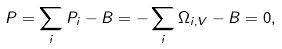<formula> <loc_0><loc_0><loc_500><loc_500>P = \sum _ { i } P _ { i } - B = - \sum _ { i } \Omega _ { i , V } - B = 0 ,</formula> 